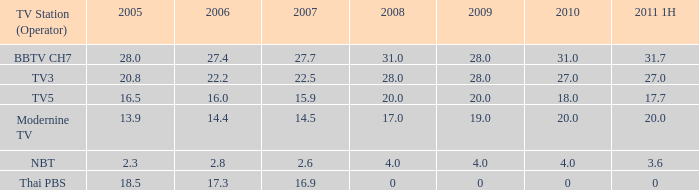What is the typical 2007 value for a 2006 of 2.6. 